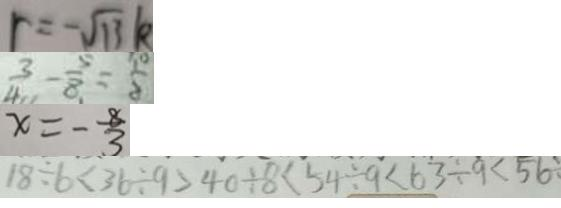<formula> <loc_0><loc_0><loc_500><loc_500>r = - \sqrt { 1 3 } k 
 \frac { 3 } { 4 } - \frac { 5 } { 8 } = \frac { 1 0 } { 8 } 
 x = - \frac { 8 } { 3 } 
 1 8 \div 6 < 3 6 \div 9 > 4 0 \div 8 < 5 4 \div 9 < 6 3 \div 9 < 5 6 \div</formula> 